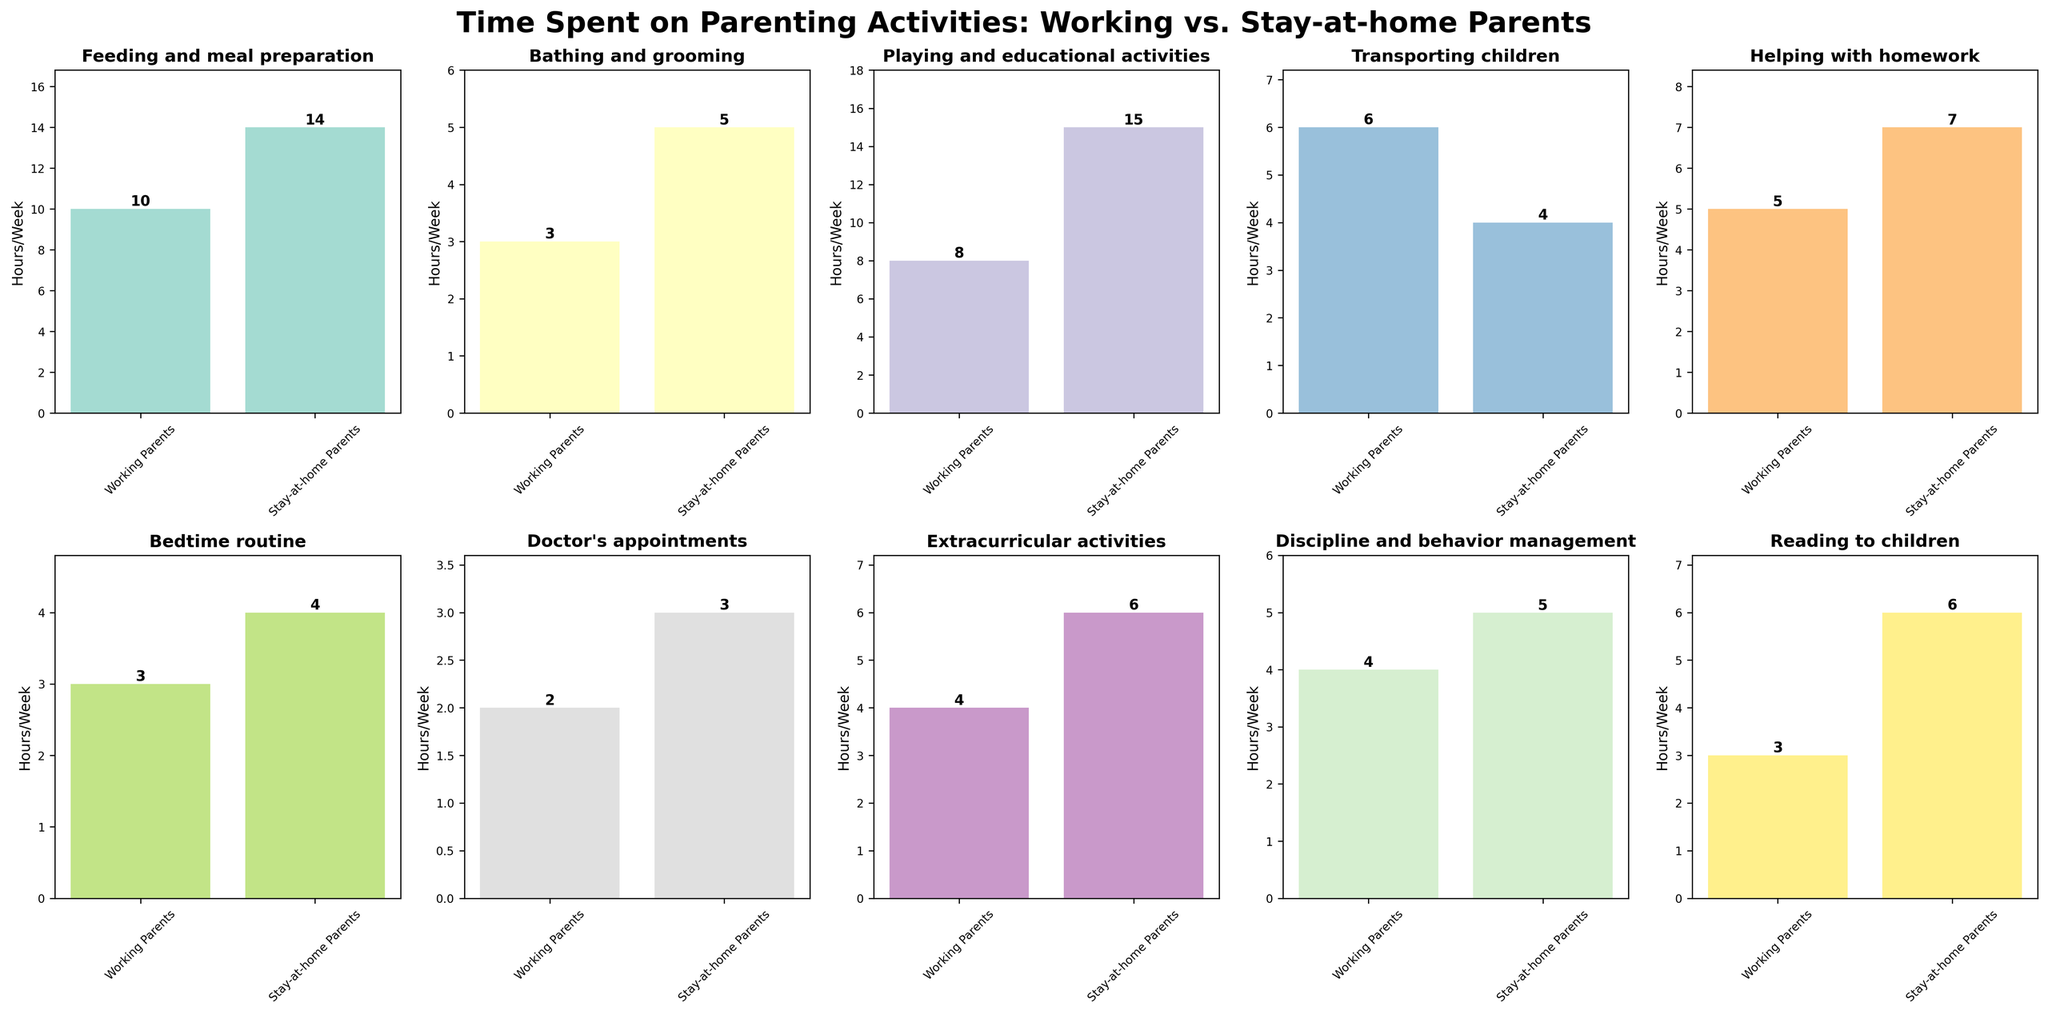what is the title of the figure? The title is presented at the top of the figure to describe its content. It reads "Time Spent on Parenting Activities: Working vs. Stay-at-home Parents," indicating a comparison of time spent by these two groups across various activities.
Answer: Time Spent on Parenting Activities: Working vs. Stay-at-home Parents How many hours per week do stay-at-home parents spend on playing and educational activities? Look at the subplot titled "Playing and educational activities" to find the bar for stay-at-home parents. The bar height, labeled at the top, shows 15 hours per week.
Answer: 15 Which activity shows the smallest difference in time spent between working and stay-at-home parents? Examine each subplot for the difference between the two bars. The smallest difference is found in "Transporting children," where working parents spend 6 hours, and stay-at-home parents spend 4 hours per week. The difference is 2 hours, the smallest among all activities.
Answer: Transporting children What are the average hours spent on reading to children for both groups combined? Add the hours spent by both groups on reading to children and then divide by 2. Working parents spend 3 hours, and stay-at-home parents spend 6 hours. (3 + 6) / 2 = 4.5 hours.
Answer: 4.5 Which group spends less time on extracurricular activities, and by how many hours? Check the subplot for "Extracurricular activities." Working parents spend 4 hours, and stay-at-home parents spend 6 hours. Working parents spend 2 hours less than stay-at-home parents.
Answer: Working parents, by 2 hours How much more time do stay-at-home parents spend on feeding and meal preparation compared to working parents? Find the hours spent by both groups on the subplot for "Feeding and meal preparation." Stay-at-home parents spend 14 hours, and working parents spend 10 hours. The difference is 14 - 10 = 4 hours.
Answer: 4 hours What is the total time spent on bedtime routines by both groups? Check the subplot for "Bedtime routine" to get the hours for both groups. Working parents spend 3 hours, and stay-at-home parents spend 4 hours. The total time is 3 + 4 = 7 hours per week.
Answer: 7 Which activity do stay-at-home parents spend exactly double the time compared to working parents? "Playing and educational activities" shows stay-at-home parents spending double the time. Stay-at-home parents spend 15 hours, and working parents spend 8 hours (15 is approximately double of 8).
Answer: Playing and educational activities Which activity shows working parents and stay-at-home parents spending almost equal time? "Transporting children" shows similar times with working parents spending 6 hours and stay-at-home parents spending 4 hours, which are close to each other compared to other activities.
Answer: Transporting children 